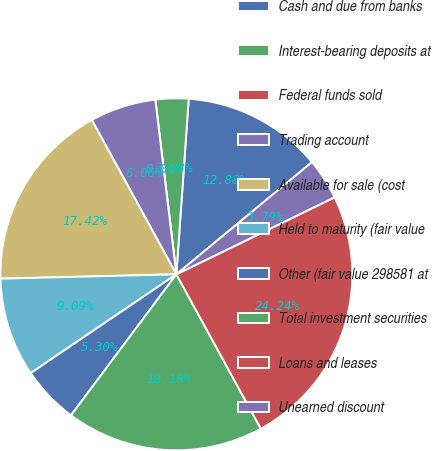Convert chart to OTSL. <chart><loc_0><loc_0><loc_500><loc_500><pie_chart><fcel>Cash and due from banks<fcel>Interest-bearing deposits at<fcel>Federal funds sold<fcel>Trading account<fcel>Available for sale (cost<fcel>Held to maturity (fair value<fcel>Other (fair value 298581 at<fcel>Total investment securities<fcel>Loans and leases<fcel>Unearned discount<nl><fcel>12.88%<fcel>3.03%<fcel>0.0%<fcel>6.06%<fcel>17.42%<fcel>9.09%<fcel>5.3%<fcel>18.18%<fcel>24.24%<fcel>3.79%<nl></chart> 